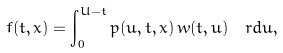Convert formula to latex. <formula><loc_0><loc_0><loc_500><loc_500>f ( t , x ) = \int _ { 0 } ^ { U - t } p ( u , t , x ) \, w ( t , u ) \, \ r d u ,</formula> 